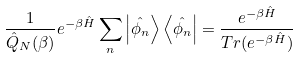Convert formula to latex. <formula><loc_0><loc_0><loc_500><loc_500>\frac { 1 } { \hat { Q } _ { N } ( \beta ) } e ^ { - \beta \hat { H } } \sum _ { n } \left | \hat { \phi _ { n } } \right \rangle \left \langle \hat { \phi _ { n } } \right | = \frac { e ^ { - \beta \hat { H } } } { T r ( e ^ { - \beta \hat { H } } ) }</formula> 